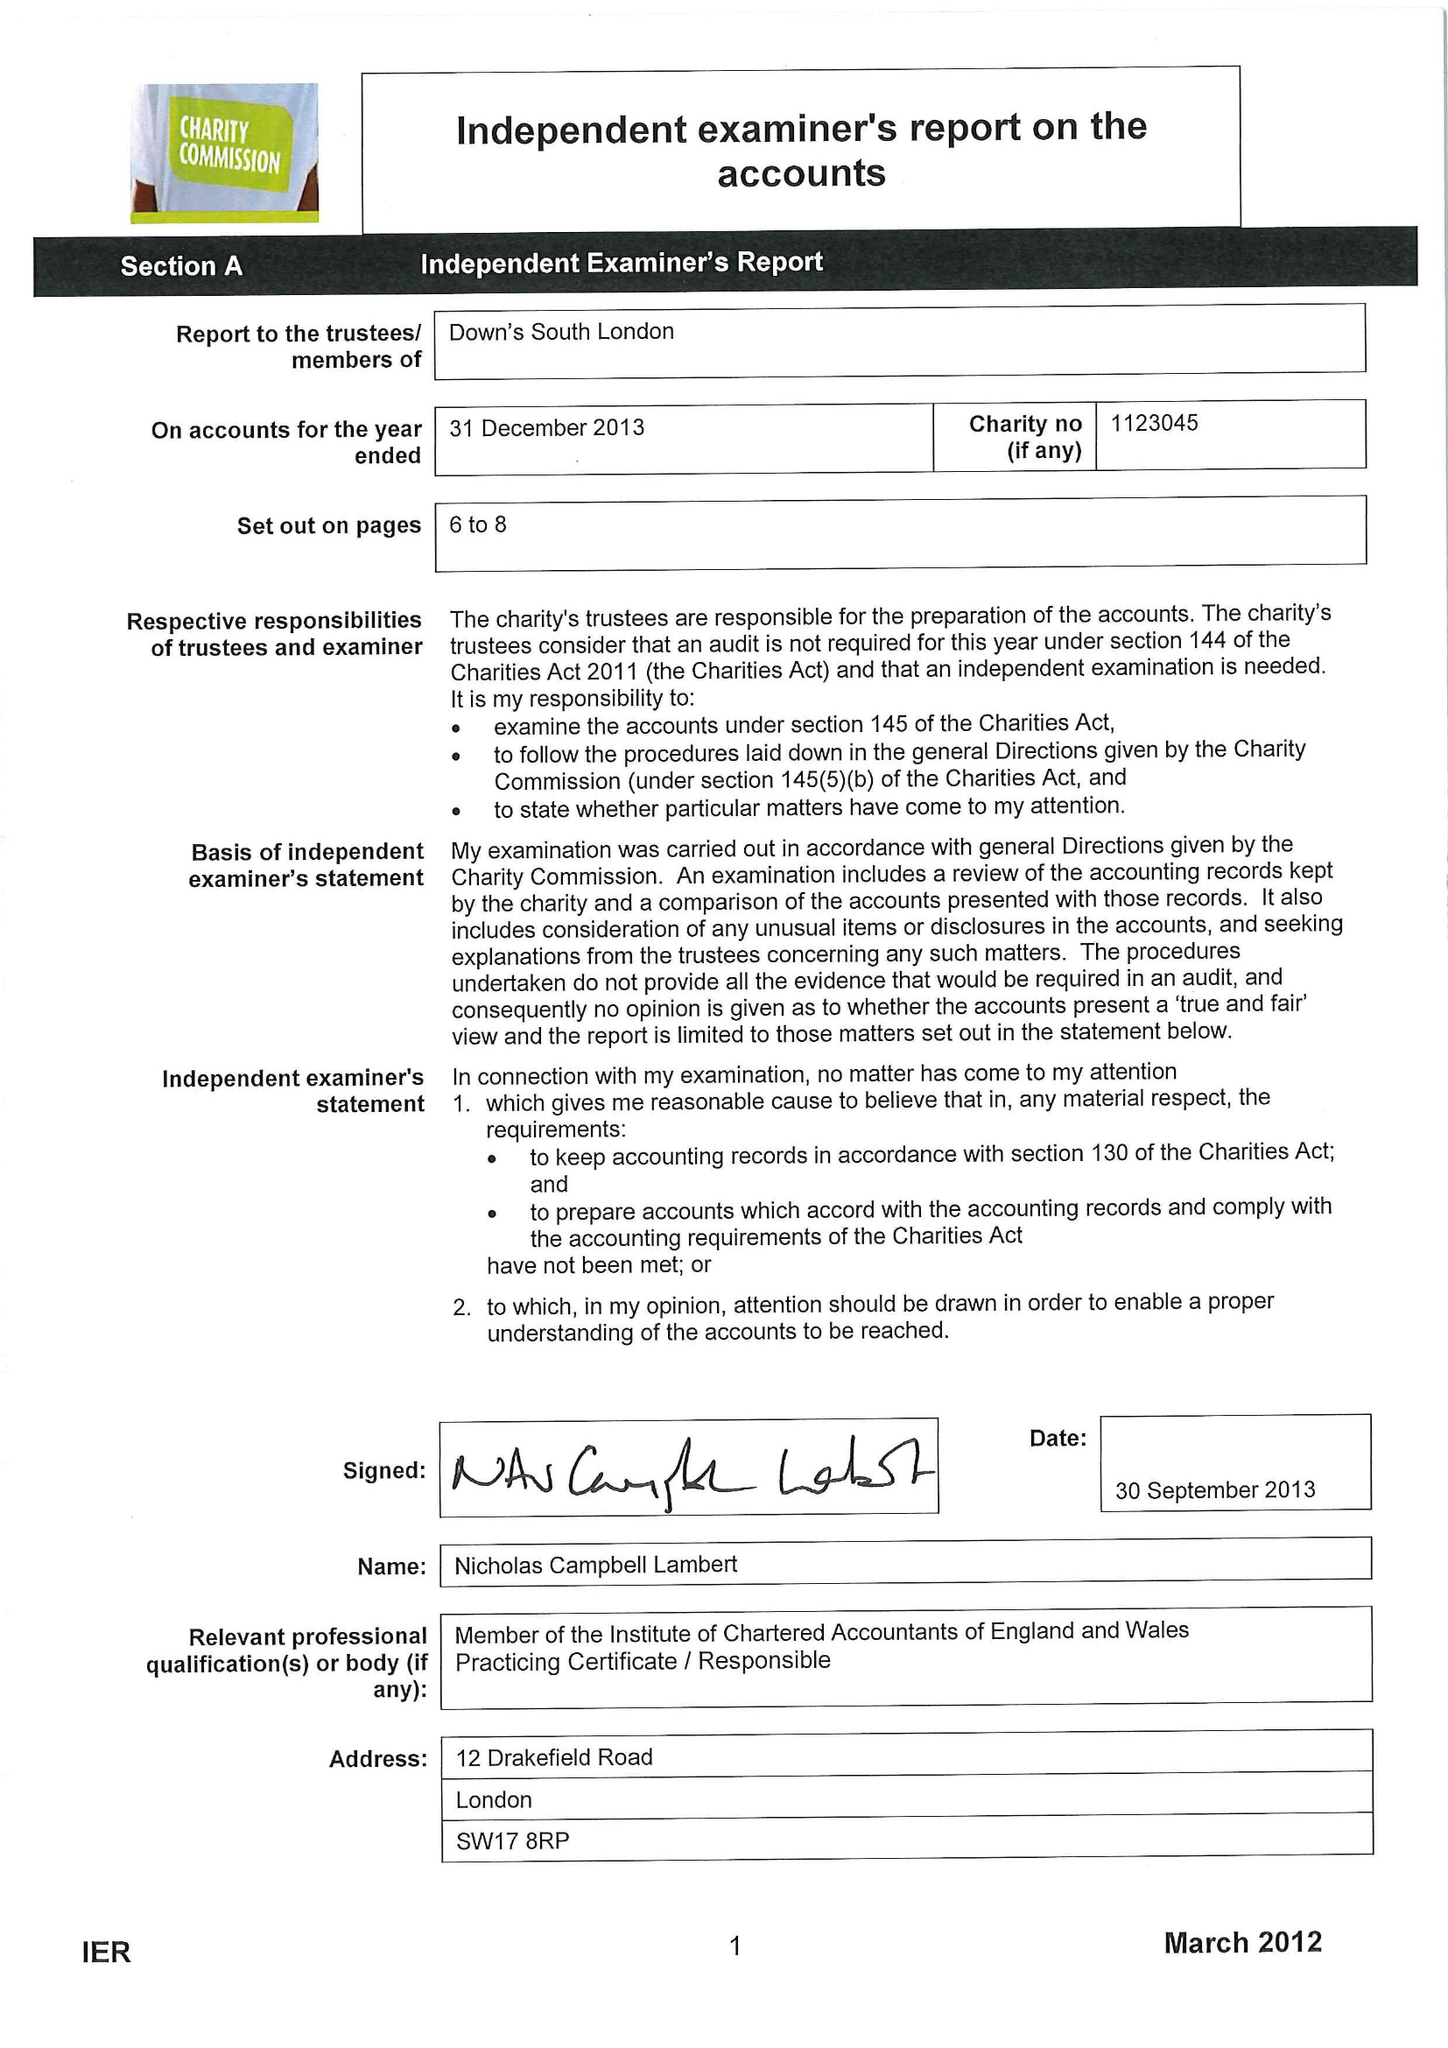What is the value for the income_annually_in_british_pounds?
Answer the question using a single word or phrase. 57521.00 